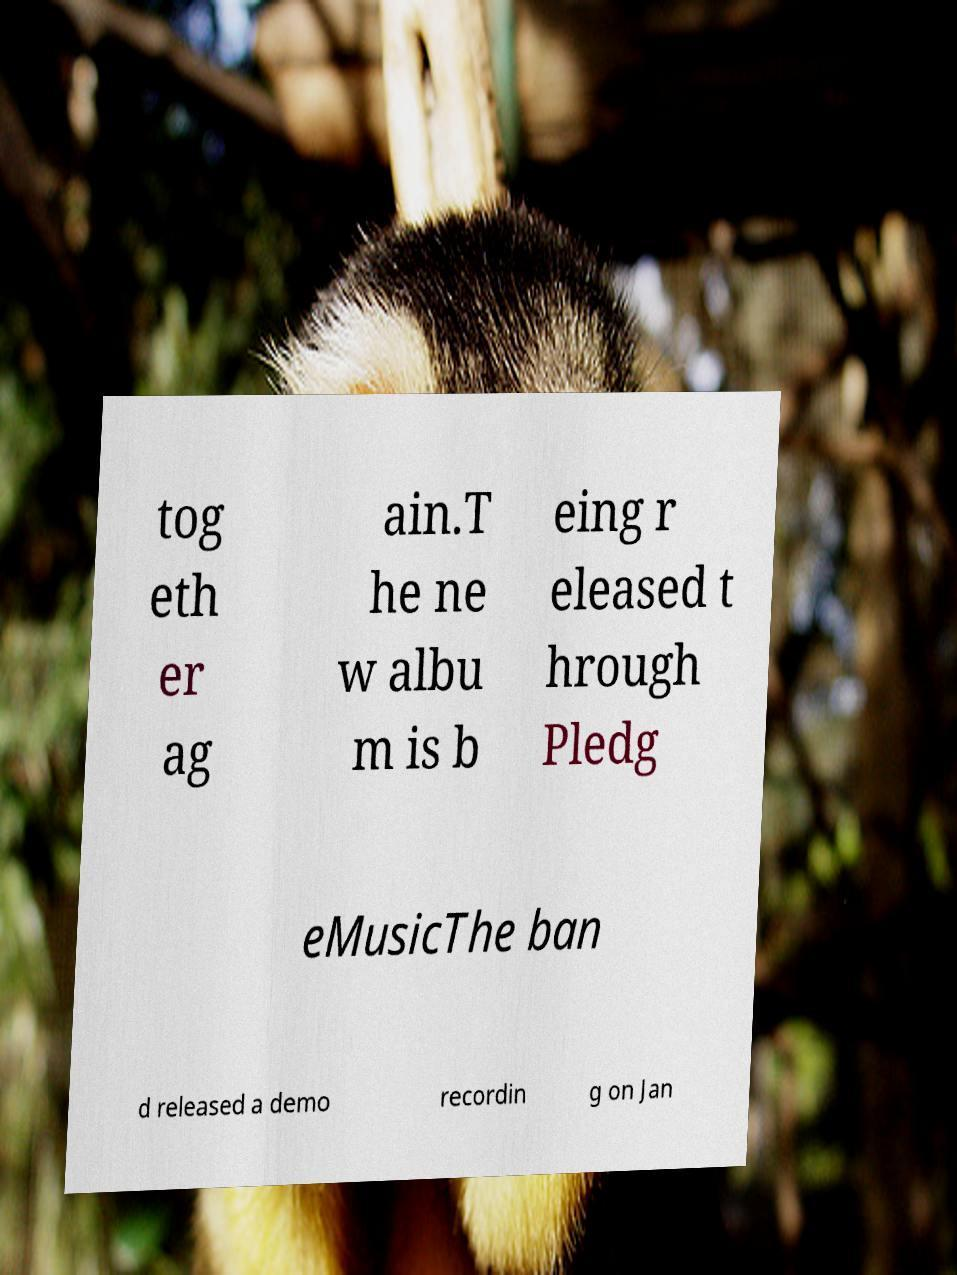What messages or text are displayed in this image? I need them in a readable, typed format. tog eth er ag ain.T he ne w albu m is b eing r eleased t hrough Pledg eMusicThe ban d released a demo recordin g on Jan 